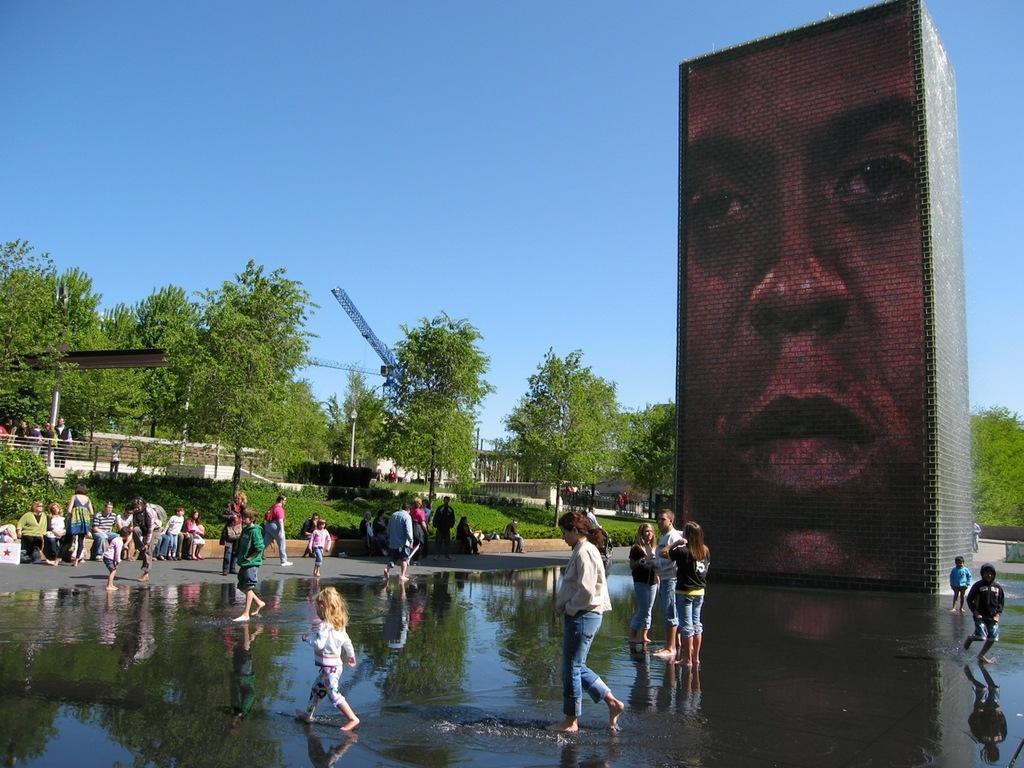Please provide a concise description of this image. At the bottom of the picture, we see water. In the middle, we see three people are standing and three people are walking in the water. On the right side, we see two boys are walking in the water. Behind them, we see a building containing the poster of a man. On the left side, we see the people are standing and some of them are sitting on the wall. Behind them, we see the grass. In the background, we see the railing, trees, poles and a tower crane. We see the people are standing on the left side. At the top, we see the sky, which is blue in color. 